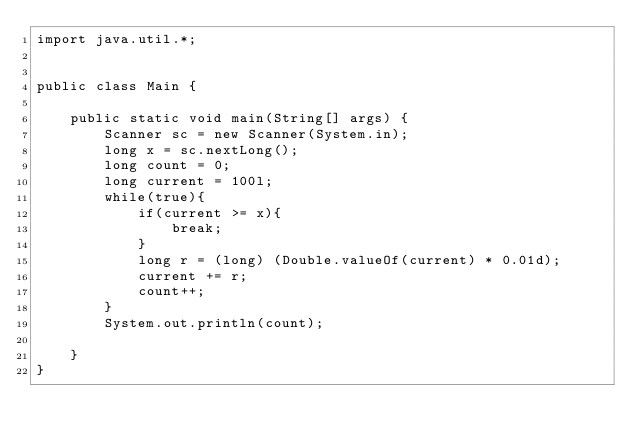<code> <loc_0><loc_0><loc_500><loc_500><_Java_>import java.util.*;


public class Main {

    public static void main(String[] args) {
        Scanner sc = new Scanner(System.in);
        long x = sc.nextLong();
        long count = 0;
        long current = 100l;
        while(true){
            if(current >= x){
                break;
            }
            long r = (long) (Double.valueOf(current) * 0.01d);
            current += r;
            count++;
        }
        System.out.println(count);

    }
}</code> 